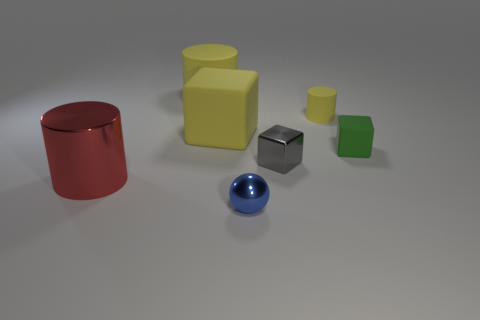There is a big object that is left of the big cylinder behind the big metal cylinder; what is its shape?
Your response must be concise. Cylinder. Is the shape of the large object behind the tiny rubber cylinder the same as  the blue metallic thing?
Your response must be concise. No. The tiny metallic block right of the yellow rubber block is what color?
Your answer should be very brief. Gray. What number of cubes are either gray shiny things or large matte objects?
Keep it short and to the point. 2. How big is the yellow object to the right of the small shiny block behind the red object?
Provide a succinct answer. Small. Is the color of the big matte cylinder the same as the small cylinder that is behind the red thing?
Your answer should be very brief. Yes. There is a blue ball; what number of yellow things are left of it?
Ensure brevity in your answer.  2. Is the number of cyan shiny spheres less than the number of shiny cylinders?
Offer a very short reply. Yes. What size is the metallic thing that is both in front of the small gray block and to the right of the large red metallic thing?
Keep it short and to the point. Small. Is the color of the cube that is behind the small green rubber object the same as the small cylinder?
Make the answer very short. Yes. 